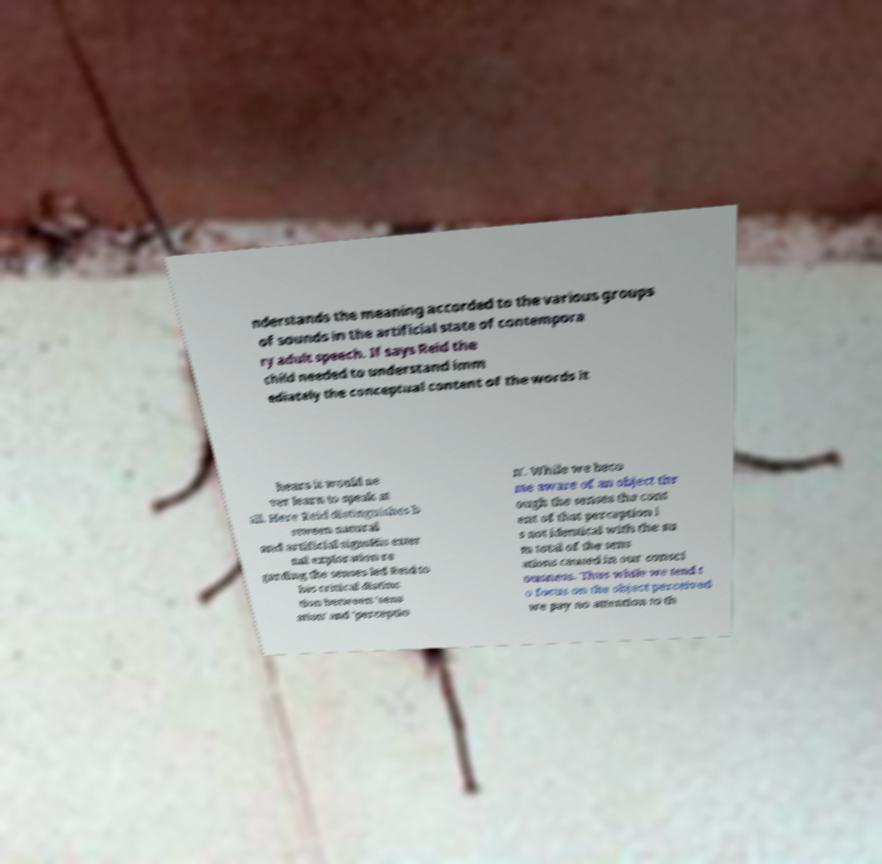Please identify and transcribe the text found in this image. nderstands the meaning accorded to the various groups of sounds in the artificial state of contempora ry adult speech. If says Reid the child needed to understand imm ediately the conceptual content of the words it hears it would ne ver learn to speak at all. Here Reid distinguishes b etween natural and artificial signsHis exter nal exploration re garding the senses led Reid to his critical distinc tion between 'sens ation' and 'perceptio n'. While we beco me aware of an object thr ough the senses the cont ent of that perception i s not identical with the su m total of the sens ations caused in our consci ousness. Thus while we tend t o focus on the object perceived we pay no attention to th 